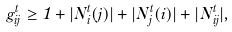<formula> <loc_0><loc_0><loc_500><loc_500>g ^ { t } _ { i j } \geq 1 + | N ^ { t } _ { i } ( j ) | + | N ^ { t } _ { j } ( i ) | + | N ^ { t } _ { i j } | ,</formula> 